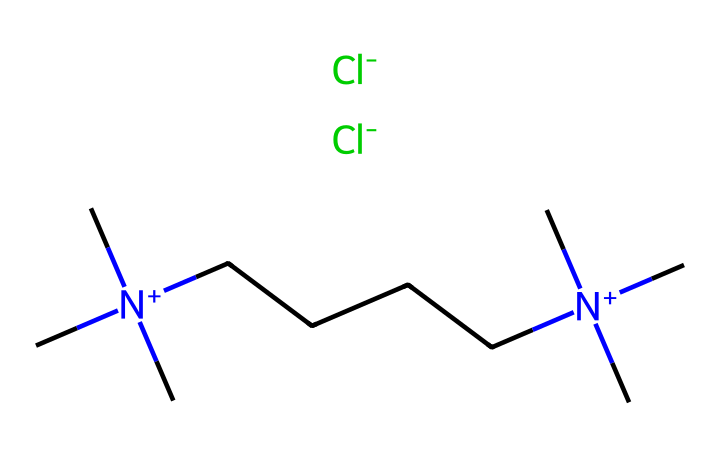What is the total number of carbon atoms in the structure? By examining the SMILES representation, we can identify the number of carbon atoms represented. The "C" symbols indicate carbon atoms, and if counted, there are a total of 12 carbon atoms in the full structure.
Answer: 12 How many nitrogen atoms are in this ionic liquid? The structure contains "N+", which denotes positively charged nitrogen atoms. Counting the occurrences, there are 2 nitrogen atoms present in the compound.
Answer: 2 What anion is associated with this ionic liquid? The "[Cl-]" part of the SMILES indicates the presence of chlorine as the anion, which is clearly marked within the structure as negatively charged.
Answer: Cl- How many methyl groups are present in the chemical? The "C[N+](C)(C)" notation shows that there are three methyl groups (the "C" attached to the "N+" represents a methyl carbon). These occur twice in the structure, leading to a total of 6 methyl groups.
Answer: 6 What is the charge of the nitrogen atoms in this ionic liquid? The notation "N+" indicates that the nitrogen atoms have a positive charge. This information is found directly in the SMILES representation.
Answer: Positive What functional groups can be identified in this ionic liquid? Analyzing the structure, we see that the presence of the nitrogen quaternary ammonium group (C[N+](C)(C)) represents a functional group, as well as the chloride ion acting as a counter ion.
Answer: Quaternary ammonium and chloride What type of bonding is primarily present in this ionic liquid? The ionic liquid is primarily characterized by ionic bonding, which is represented by the positive charge of the nitrogen and the negative charge of the chloride ions. This distinction can be derived from the overall structure and charge characteristics in the SMILES.
Answer: Ionic bonding 